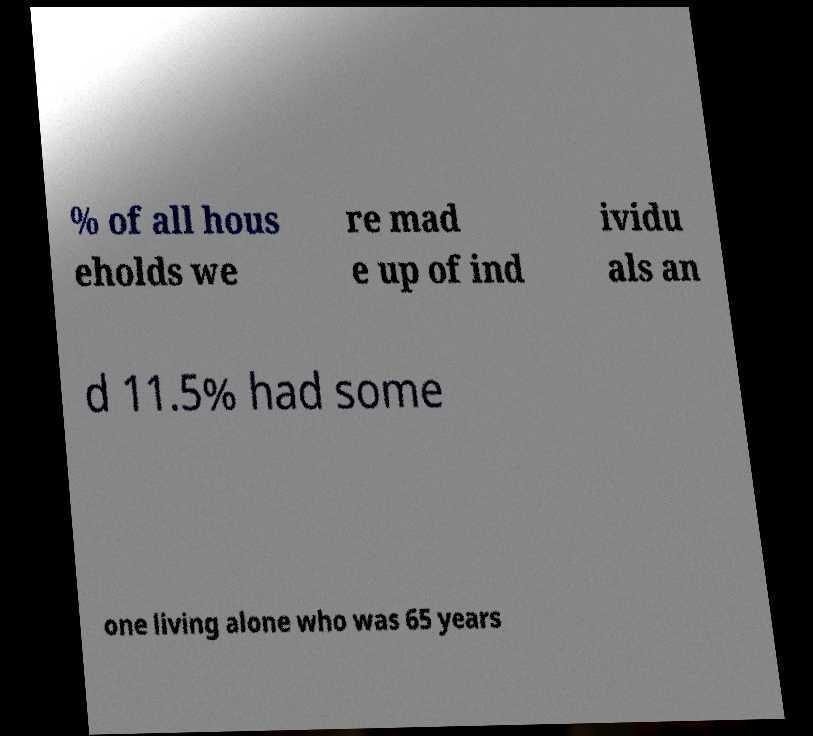Could you assist in decoding the text presented in this image and type it out clearly? % of all hous eholds we re mad e up of ind ividu als an d 11.5% had some one living alone who was 65 years 